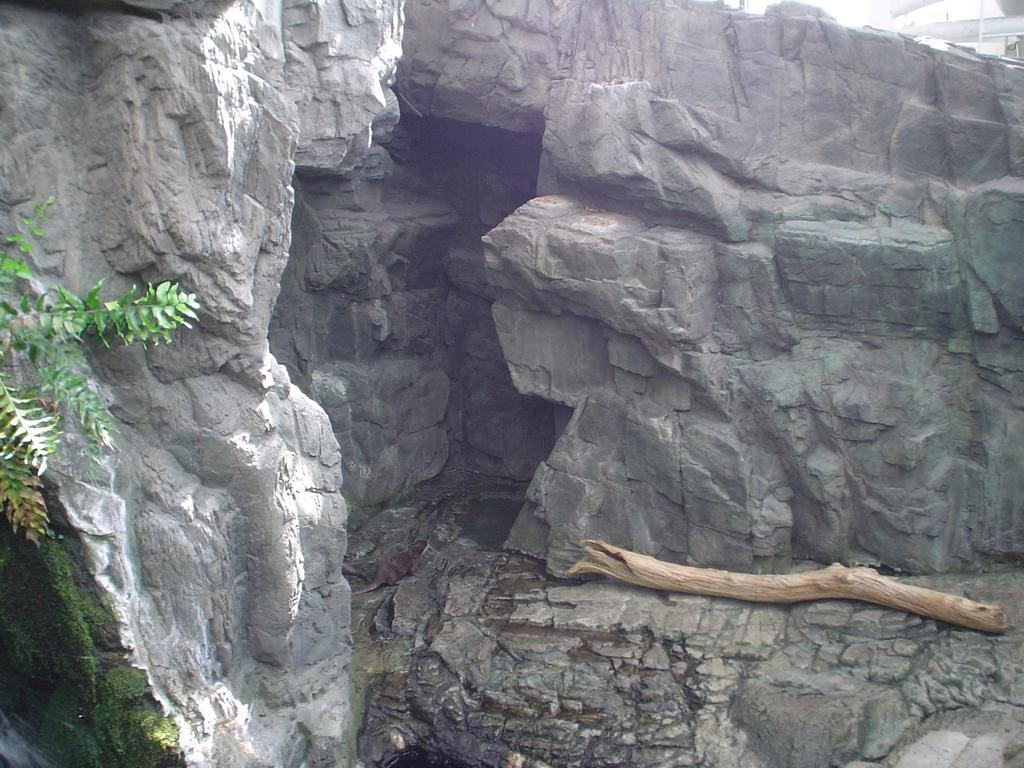What type of natural formation can be seen in the image? There are rocks in the image. What is located near the rocks in the image? There are hills near the rocks in the image. What type of vegetation is present in the image? There are plants in the image. What is covering some of the rocks in the image? Some moss is present on the rocks. What is attached to the tree in the image? There is a stick attached to the tree in the image. What type of popcorn can be seen growing on the rocks in the image? There is no popcorn present in the image; it is a natural landscape with rocks, hills, plants, moss, and a tree with a stick. What discovery was made near the rocks in the image? There is no mention of a discovery in the image; it simply depicts a natural landscape. 